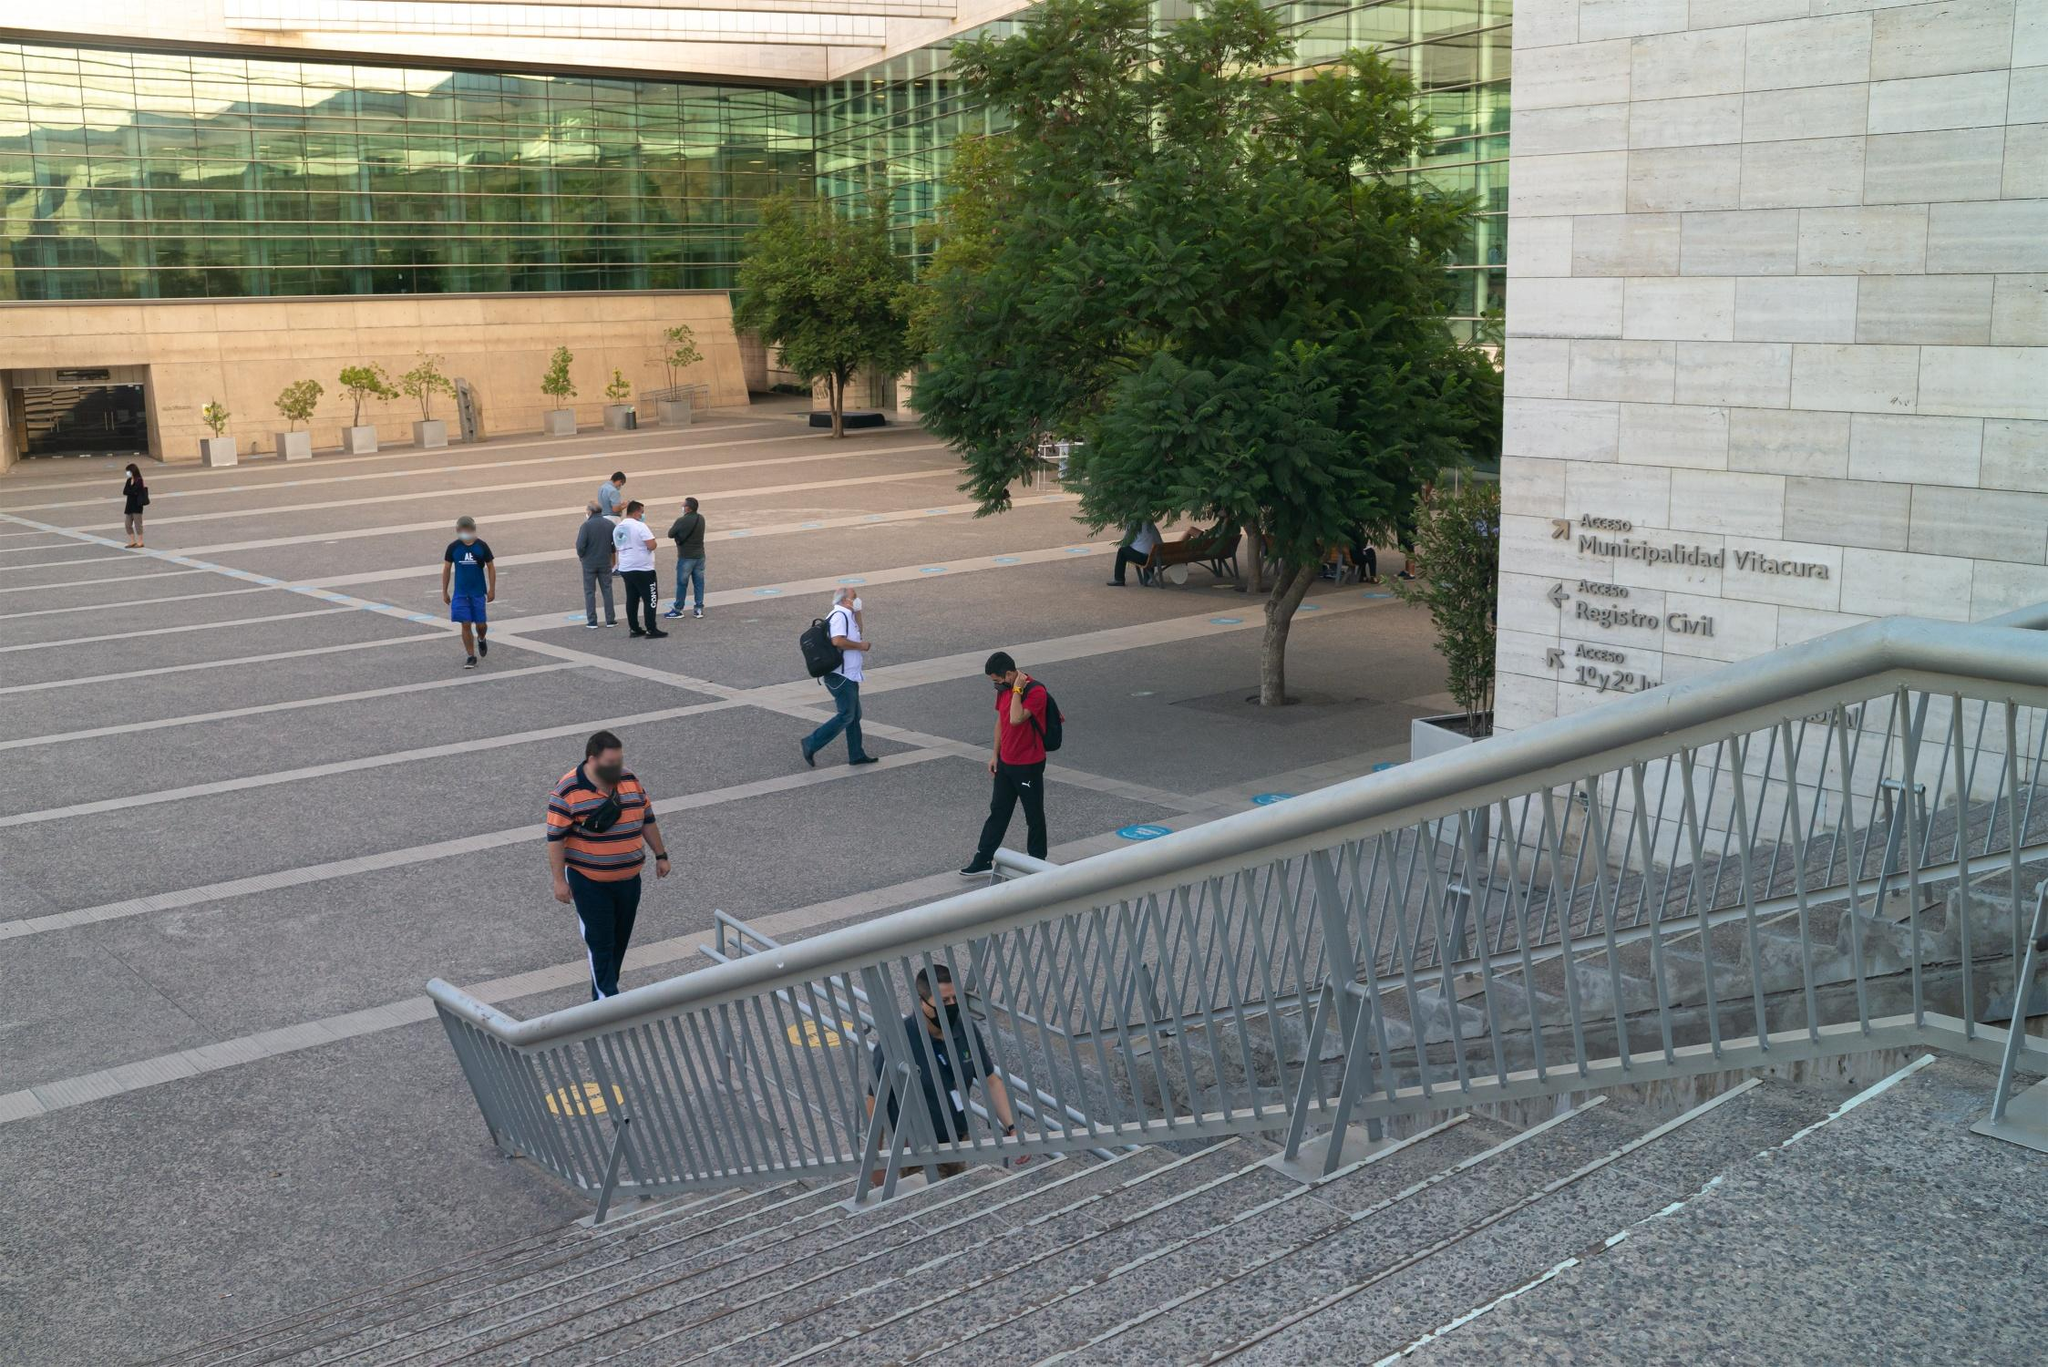Can you describe the architectural style of the building visible in the image? The building exhibits characteristics of modern architecture, with its use of large glass panels that allow ample natural light to permeate the interior spaces. The exterior walls are made of light-colored stone, providing a clean and sleek look. The overall design focuses on simplicity and functionality, with minimal ornamental elements, which is typical of contemporary municipal buildings. 